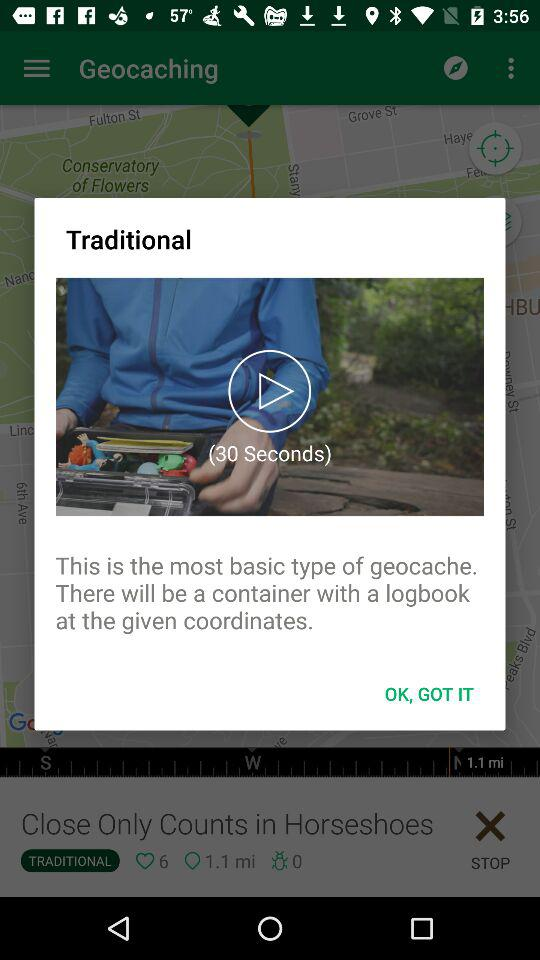How many likes are there of "Close Only Counts in Horseshoes"? There are 6 likes. 